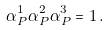Convert formula to latex. <formula><loc_0><loc_0><loc_500><loc_500>\alpha _ { P } ^ { 1 } \alpha _ { P } ^ { 2 } \alpha _ { P } ^ { 3 } = 1 \, .</formula> 